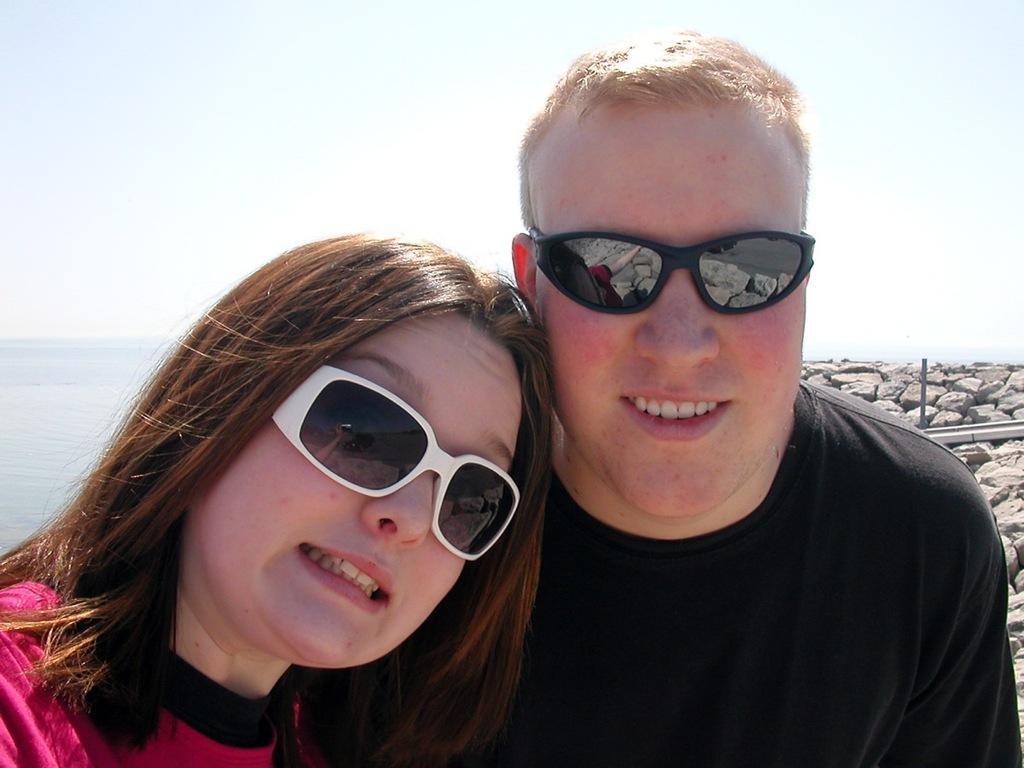Could you give a brief overview of what you see in this image? In this image there is a man and a woman wearing glasses, in the background there are stones, sea and the sky. 